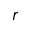<formula> <loc_0><loc_0><loc_500><loc_500>r</formula> 